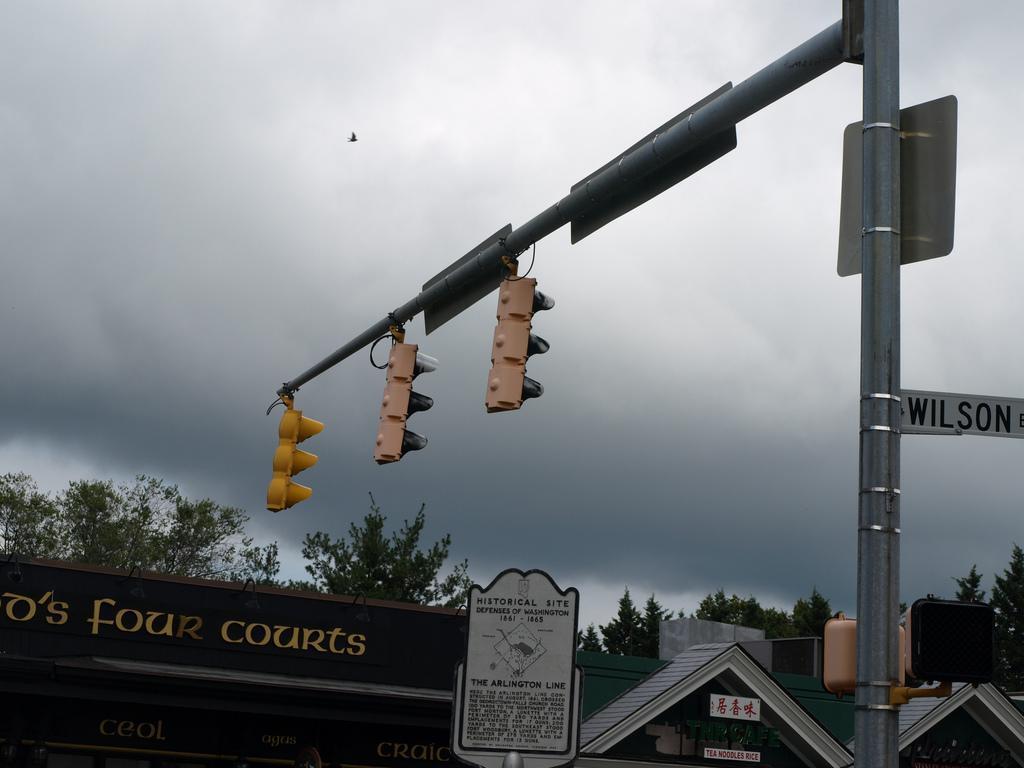How many stop lights are hanging on the pole?
Give a very brief answer. 3. How many stoplights are hanging over the street?
Give a very brief answer. 3. How many traffic signals are peach?
Give a very brief answer. 2. How many traffic signals are there?
Give a very brief answer. 3. How many traffic lights are pictured?
Give a very brief answer. 3. How many traffic lights are bright yellow?
Give a very brief answer. 1. How many streetlights are there?
Give a very brief answer. 3. 